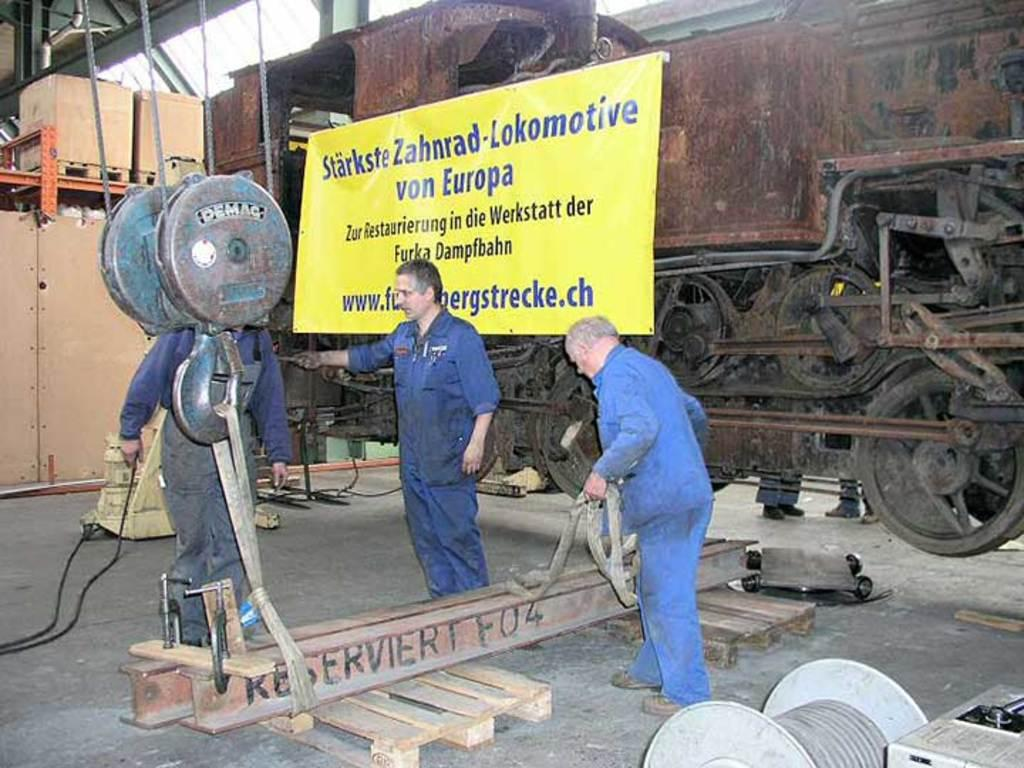How many people are in the image? There are three persons standing in the image. What is the person in front wearing? The person in front is wearing a blue dress. What else can be seen in the image besides the people? There are machines visible in the image. What is in the background of the image? There is a banner in the background of the image. What color is the banner? The banner is yellow in color. How many houses are visible in the image? There are no houses visible in the image. What type of heart is being displayed on the banner? There is no heart displayed on the banner; it is yellow in color. 